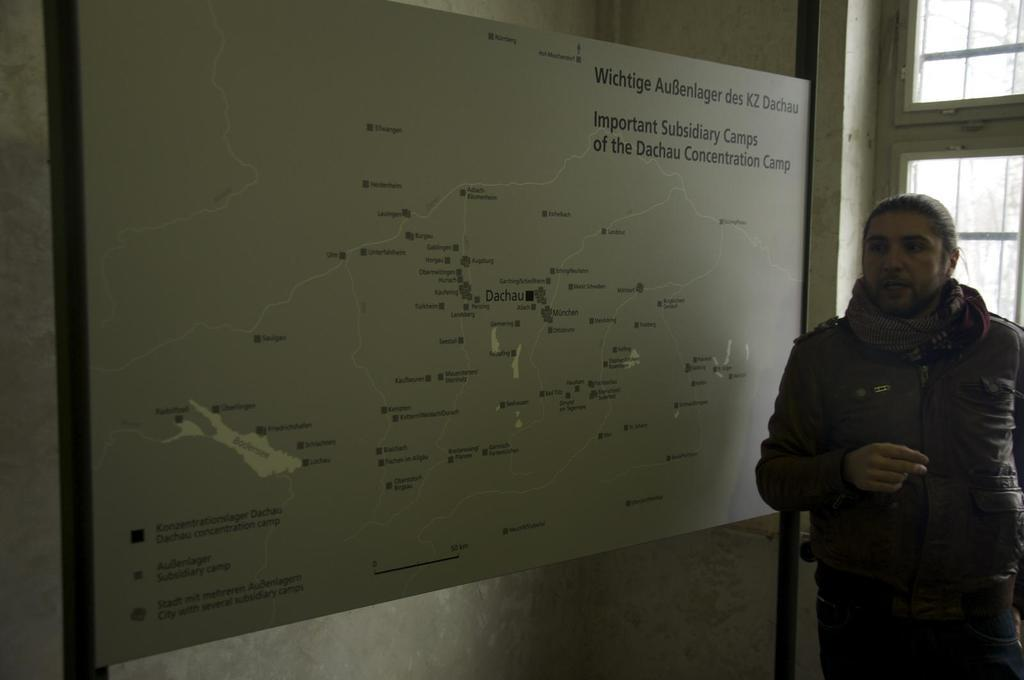What is the person in the image doing? There is a person standing beside a window in the image. What other object can be seen in the image besides the person and the window? There is a board with text on it in the image. What type of cabbage is being sold on the board in the image? There is no cabbage present in the image; the board has text on it, but it does not mention cabbage. 